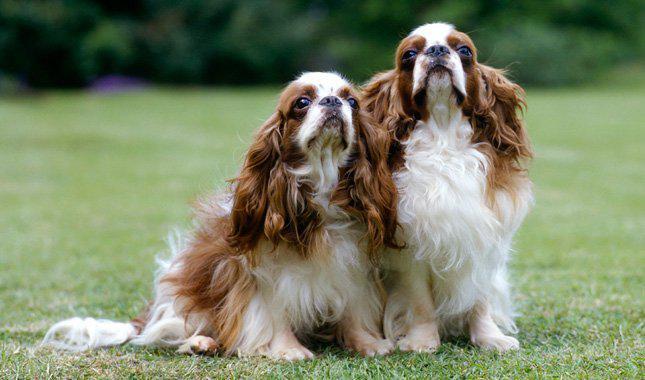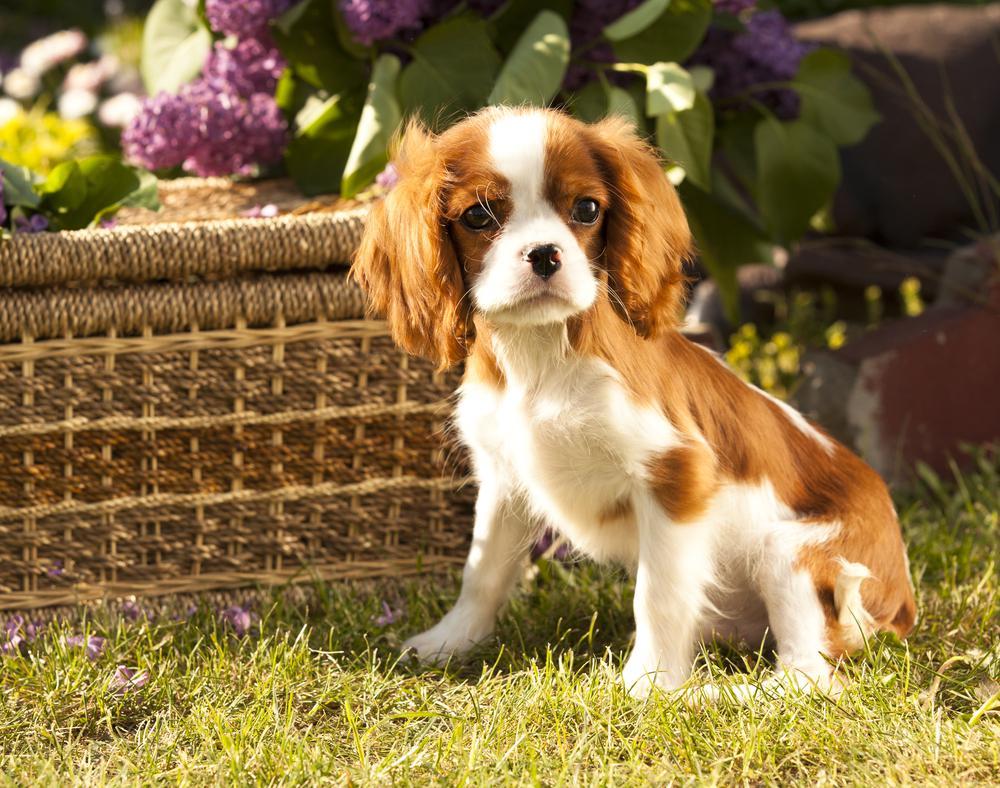The first image is the image on the left, the second image is the image on the right. Assess this claim about the two images: "There are a total of three cocker spaniels". Correct or not? Answer yes or no. Yes. The first image is the image on the left, the second image is the image on the right. Examine the images to the left and right. Is the description "One image includes twice as many dogs as the other image." accurate? Answer yes or no. Yes. 